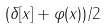<formula> <loc_0><loc_0><loc_500><loc_500>( \delta [ x ] + \varphi ( x ) ) / 2</formula> 